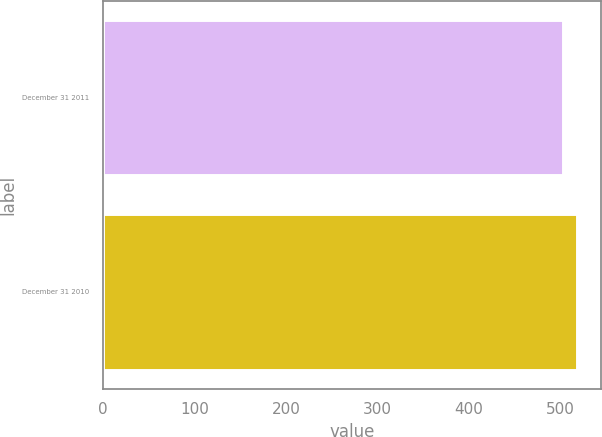Convert chart to OTSL. <chart><loc_0><loc_0><loc_500><loc_500><bar_chart><fcel>December 31 2011<fcel>December 31 2010<nl><fcel>502.5<fcel>517.9<nl></chart> 